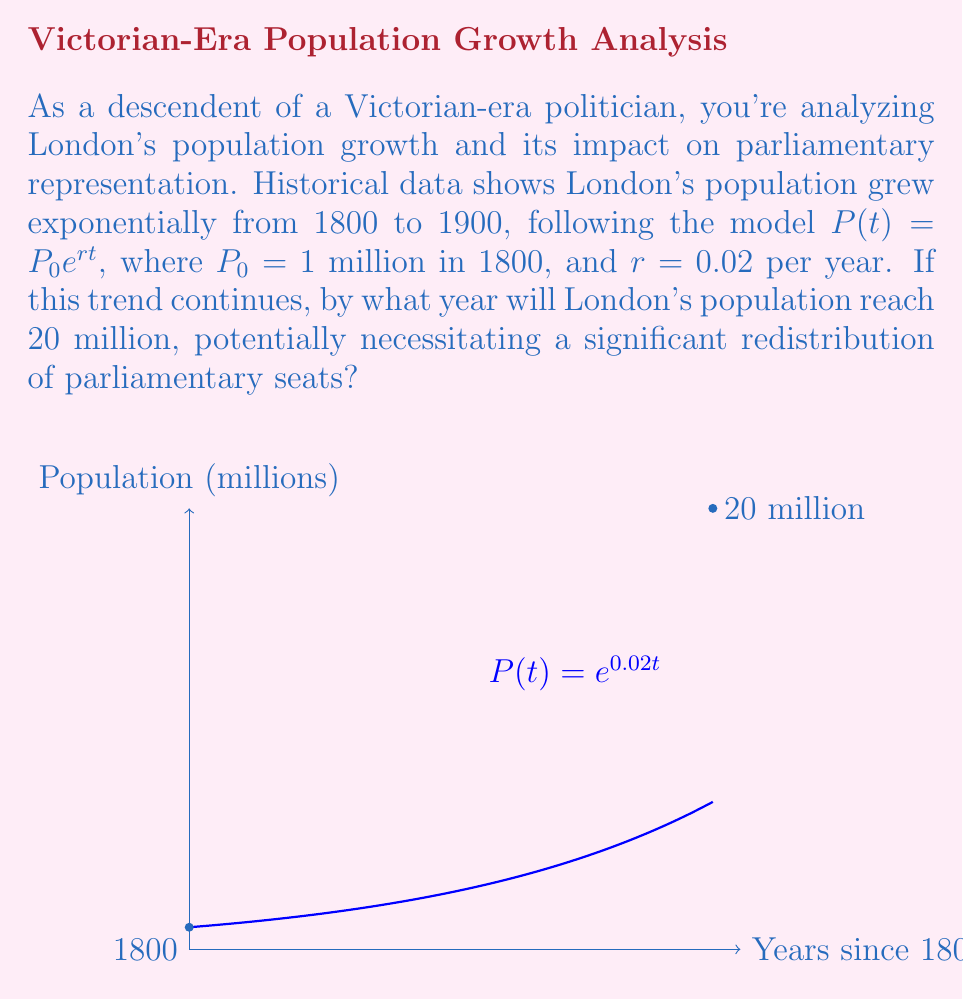What is the answer to this math problem? Let's approach this step-by-step:

1) We're given the exponential growth model: $P(t) = P_0e^{rt}$
   Where $P_0 = 1$ million, $r = 0.02$ per year, and $t$ is years since 1800.

2) We want to find when $P(t) = 20$ million. So we set up the equation:
   $20 = 1e^{0.02t}$

3) Simplify:
   $20 = e^{0.02t}$

4) Take the natural log of both sides:
   $\ln(20) = \ln(e^{0.02t})$

5) Simplify the right side using log properties:
   $\ln(20) = 0.02t$

6) Solve for $t$:
   $t = \frac{\ln(20)}{0.02} \approx 149.74$ years

7) Since $t$ is years since 1800, we add 1800 to get the actual year:
   $1800 + 149.74 \approx 1949.74$

Therefore, London's population would reach 20 million around 1950 if this growth trend continued.
Answer: 1950 